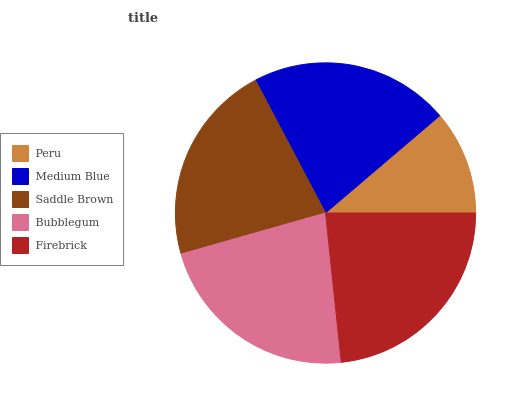Is Peru the minimum?
Answer yes or no. Yes. Is Firebrick the maximum?
Answer yes or no. Yes. Is Medium Blue the minimum?
Answer yes or no. No. Is Medium Blue the maximum?
Answer yes or no. No. Is Medium Blue greater than Peru?
Answer yes or no. Yes. Is Peru less than Medium Blue?
Answer yes or no. Yes. Is Peru greater than Medium Blue?
Answer yes or no. No. Is Medium Blue less than Peru?
Answer yes or no. No. Is Saddle Brown the high median?
Answer yes or no. Yes. Is Saddle Brown the low median?
Answer yes or no. Yes. Is Medium Blue the high median?
Answer yes or no. No. Is Firebrick the low median?
Answer yes or no. No. 